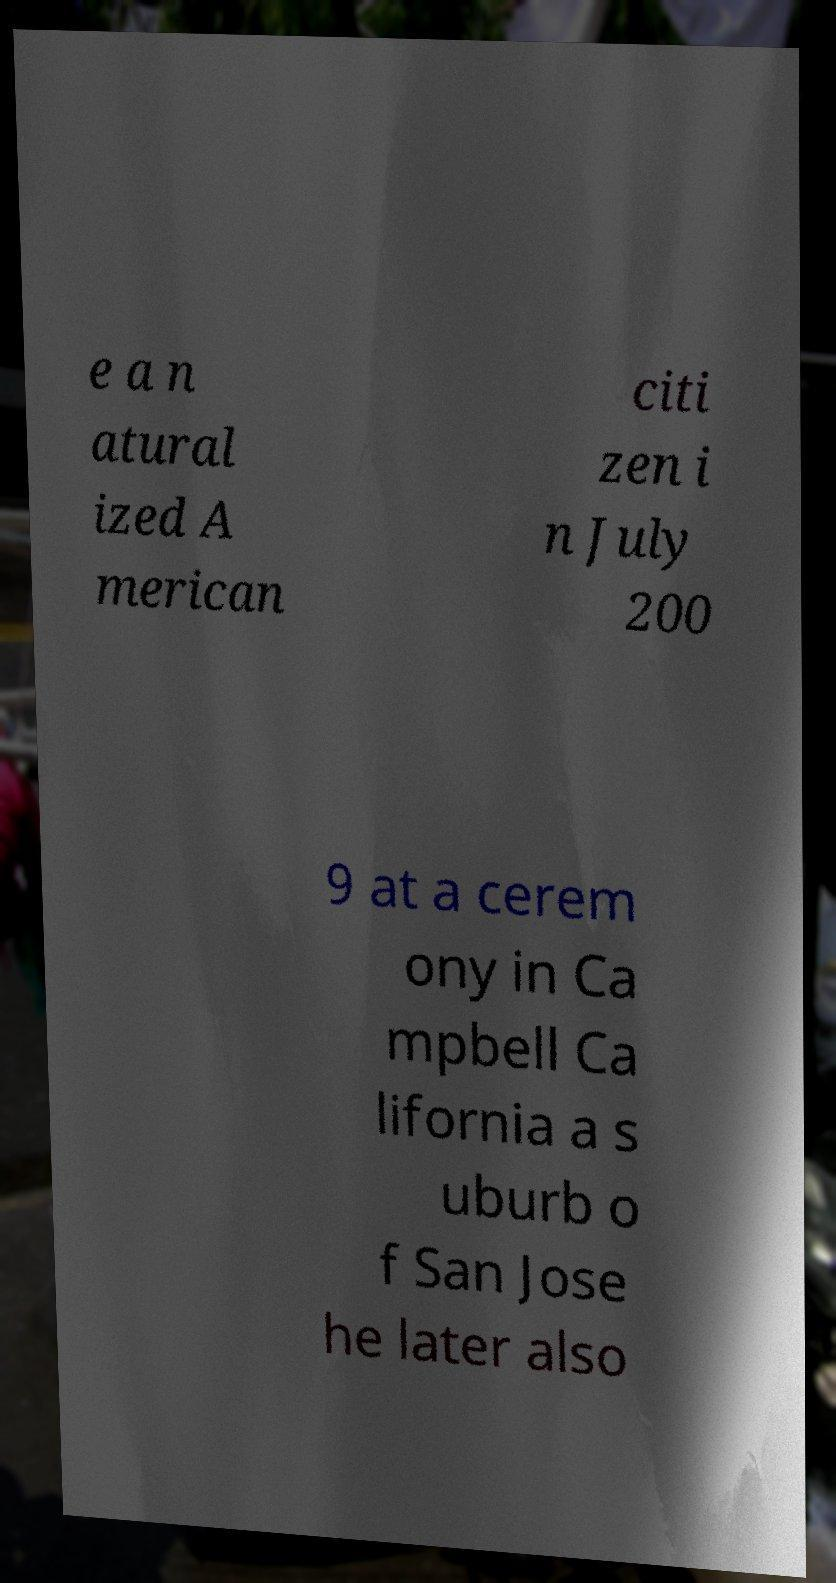Can you accurately transcribe the text from the provided image for me? e a n atural ized A merican citi zen i n July 200 9 at a cerem ony in Ca mpbell Ca lifornia a s uburb o f San Jose he later also 